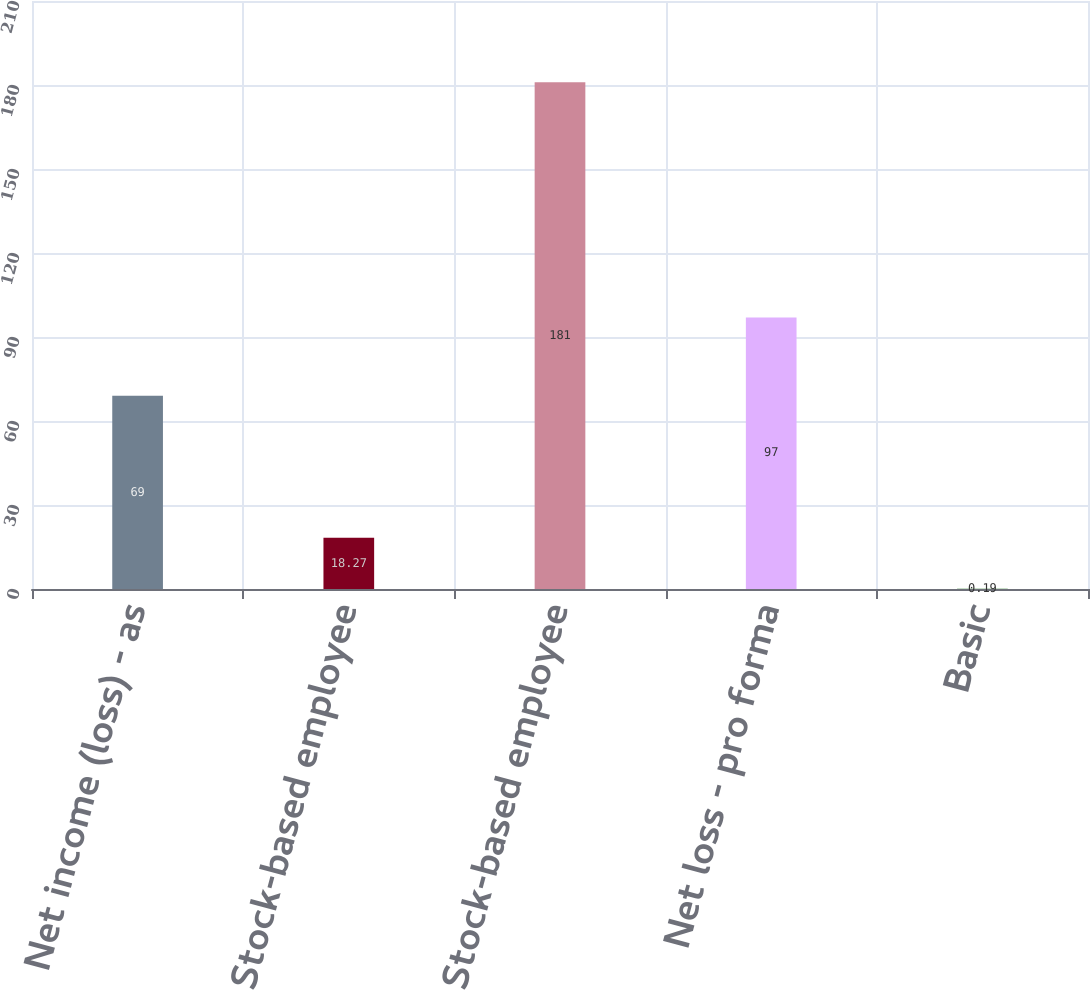Convert chart to OTSL. <chart><loc_0><loc_0><loc_500><loc_500><bar_chart><fcel>Net income (loss) - as<fcel>Add Stock-based employee<fcel>Deduct Stock-based employee<fcel>Net loss - pro forma<fcel>Basic<nl><fcel>69<fcel>18.27<fcel>181<fcel>97<fcel>0.19<nl></chart> 